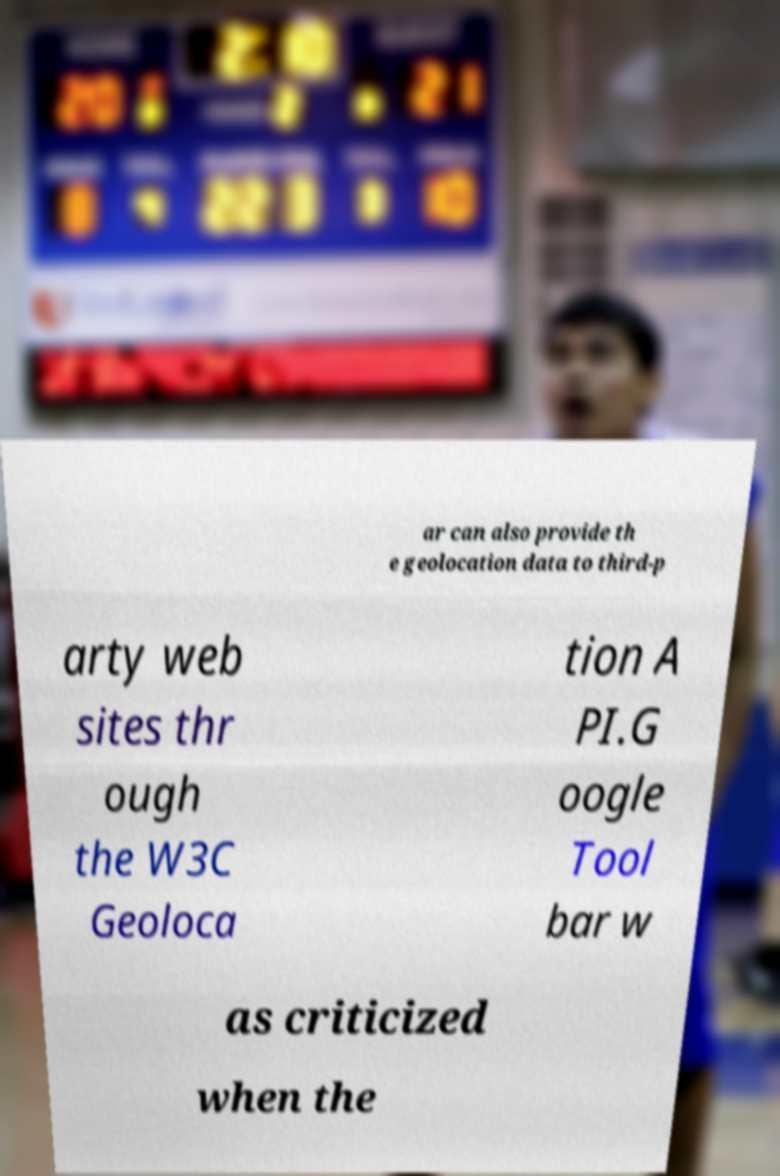Can you accurately transcribe the text from the provided image for me? ar can also provide th e geolocation data to third-p arty web sites thr ough the W3C Geoloca tion A PI.G oogle Tool bar w as criticized when the 